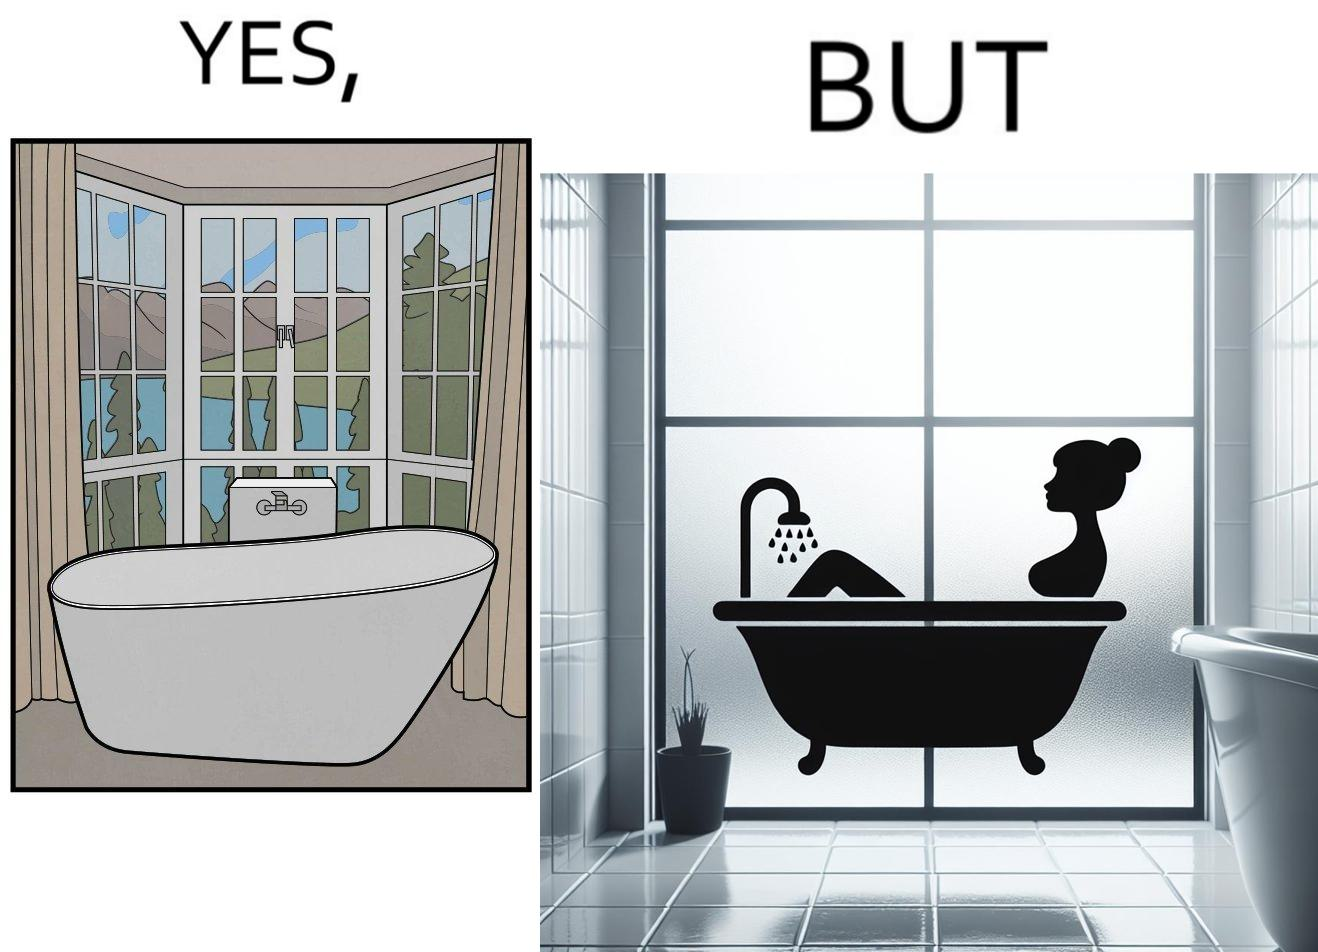Explain why this image is satirical. The image is ironical, as a bathtub near a window having a very scenic view, becomes misty when someone is bathing, thus making the scenic view blurry. 